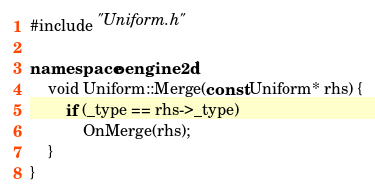<code> <loc_0><loc_0><loc_500><loc_500><_C++_>#include "Uniform.h"

namespace oengine2d {
	void Uniform::Merge(const Uniform* rhs) {
		if (_type == rhs->_type)
			OnMerge(rhs);
	}
}
</code> 